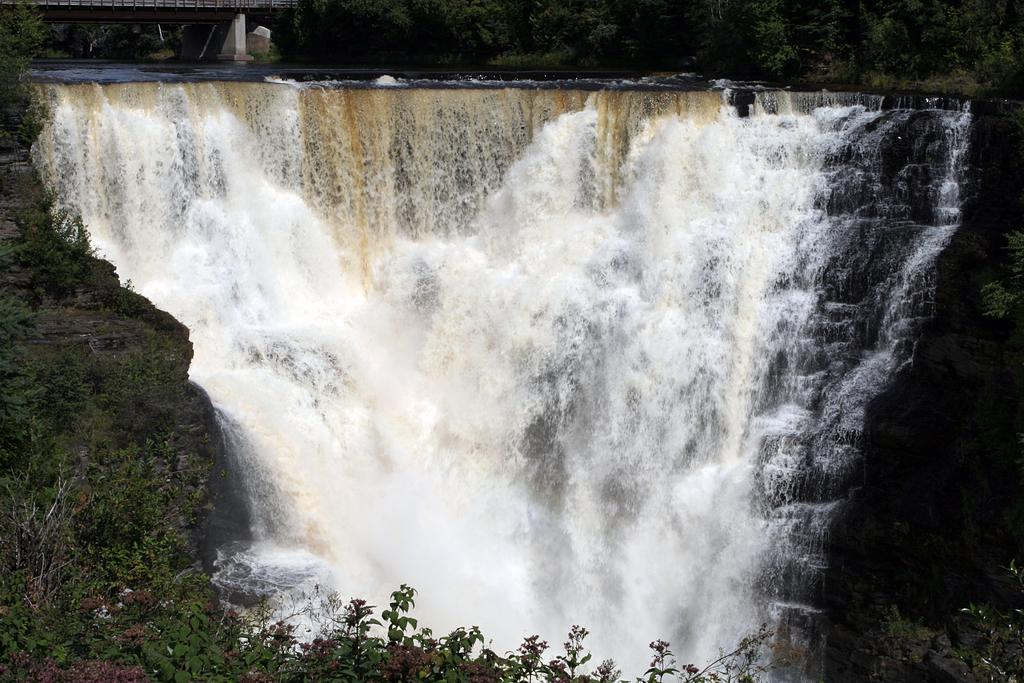What natural feature is the main subject of the image? There is a waterfall in the image. What can be seen at the base of the waterfall? There are plants at the bottom of the waterfall. What man-made structure is visible near the top of the waterfall? There is a bridge at the top of the waterfall. What type of vegetation is present near the top of the waterfall? There are trees at the top of the waterfall. Can you tell me how many monkeys are sitting on the bridge in the image? There are no monkeys present in the image; it features a waterfall, plants, a bridge, and trees. What is the temper of the waterfall in the image? The temper of the waterfall cannot be determined from the image, as it is a natural feature and not a living being with emotions. 